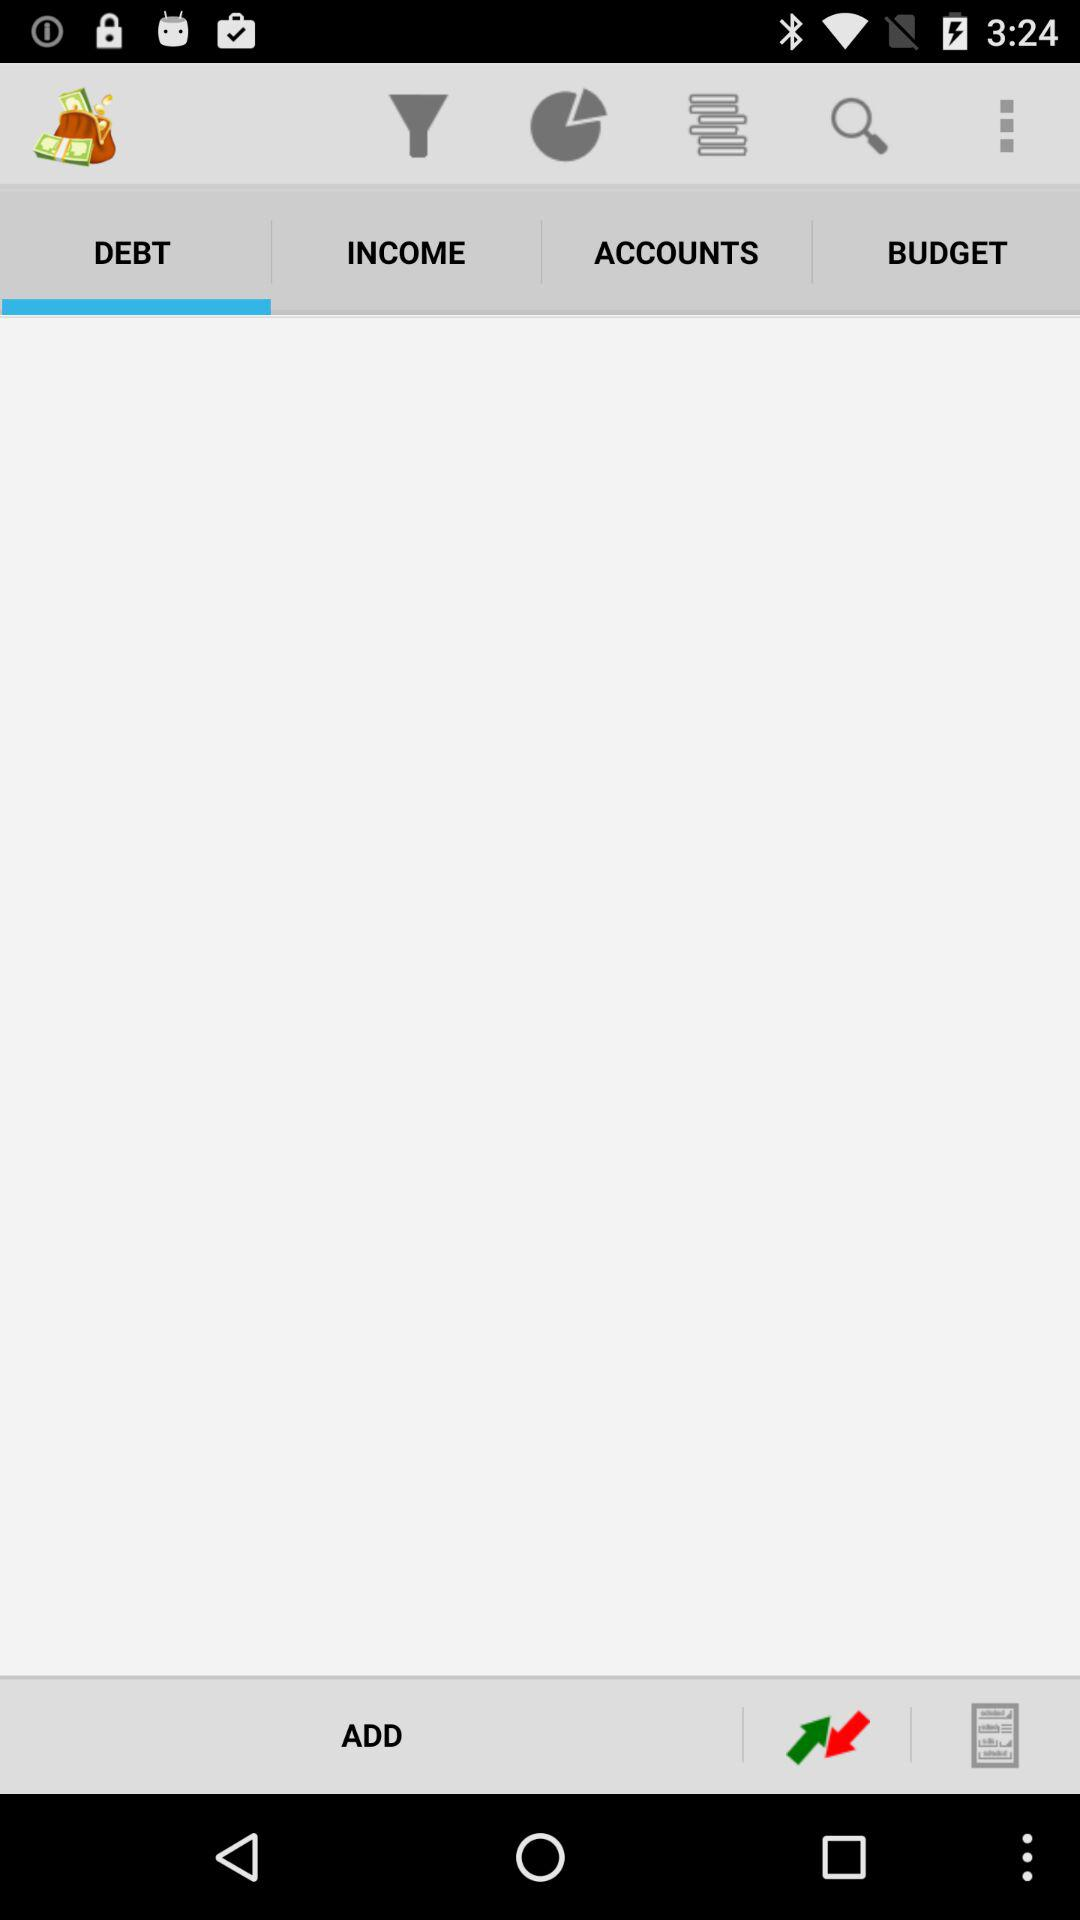Which tab is selected? The selected tab is "DEBT". 